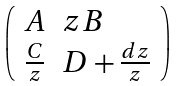Convert formula to latex. <formula><loc_0><loc_0><loc_500><loc_500>\left ( \begin{array} { l l } A & z B \\ \frac { C } { z } & D + \frac { d z } { z } \end{array} \right )</formula> 